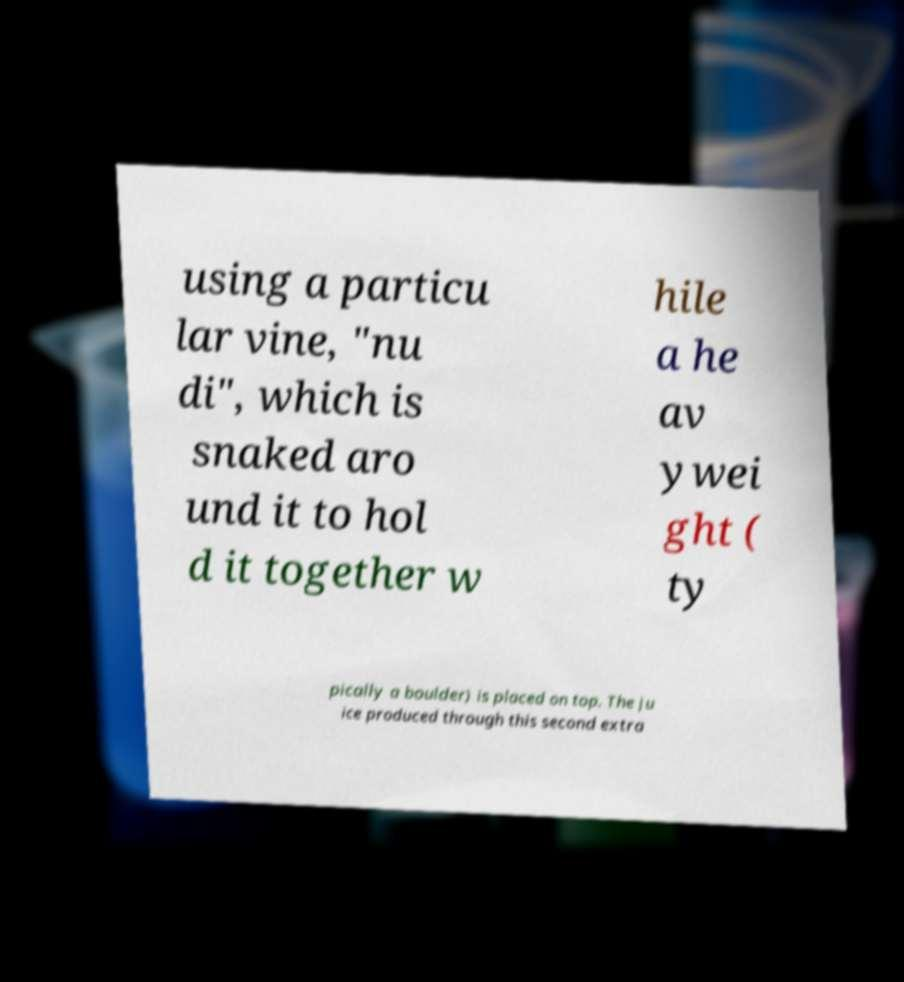Can you accurately transcribe the text from the provided image for me? using a particu lar vine, "nu di", which is snaked aro und it to hol d it together w hile a he av ywei ght ( ty pically a boulder) is placed on top. The ju ice produced through this second extra 